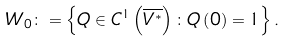Convert formula to latex. <formula><loc_0><loc_0><loc_500><loc_500>W _ { 0 } \colon = \left \{ Q \in C ^ { 1 } \left ( \overline { V ^ { \ast } } \right ) \colon Q \left ( 0 \right ) = 1 \right \} .</formula> 